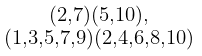Convert formula to latex. <formula><loc_0><loc_0><loc_500><loc_500>\begin{smallmatrix} ( 2 , 7 ) ( 5 , 1 0 ) , \\ ( 1 , 3 , 5 , 7 , 9 ) ( 2 , 4 , 6 , 8 , 1 0 ) \end{smallmatrix}</formula> 